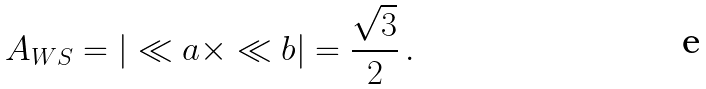<formula> <loc_0><loc_0><loc_500><loc_500>A _ { W S } = | \ll a \times \ll b | = \frac { \sqrt { 3 } } { 2 } \, .</formula> 